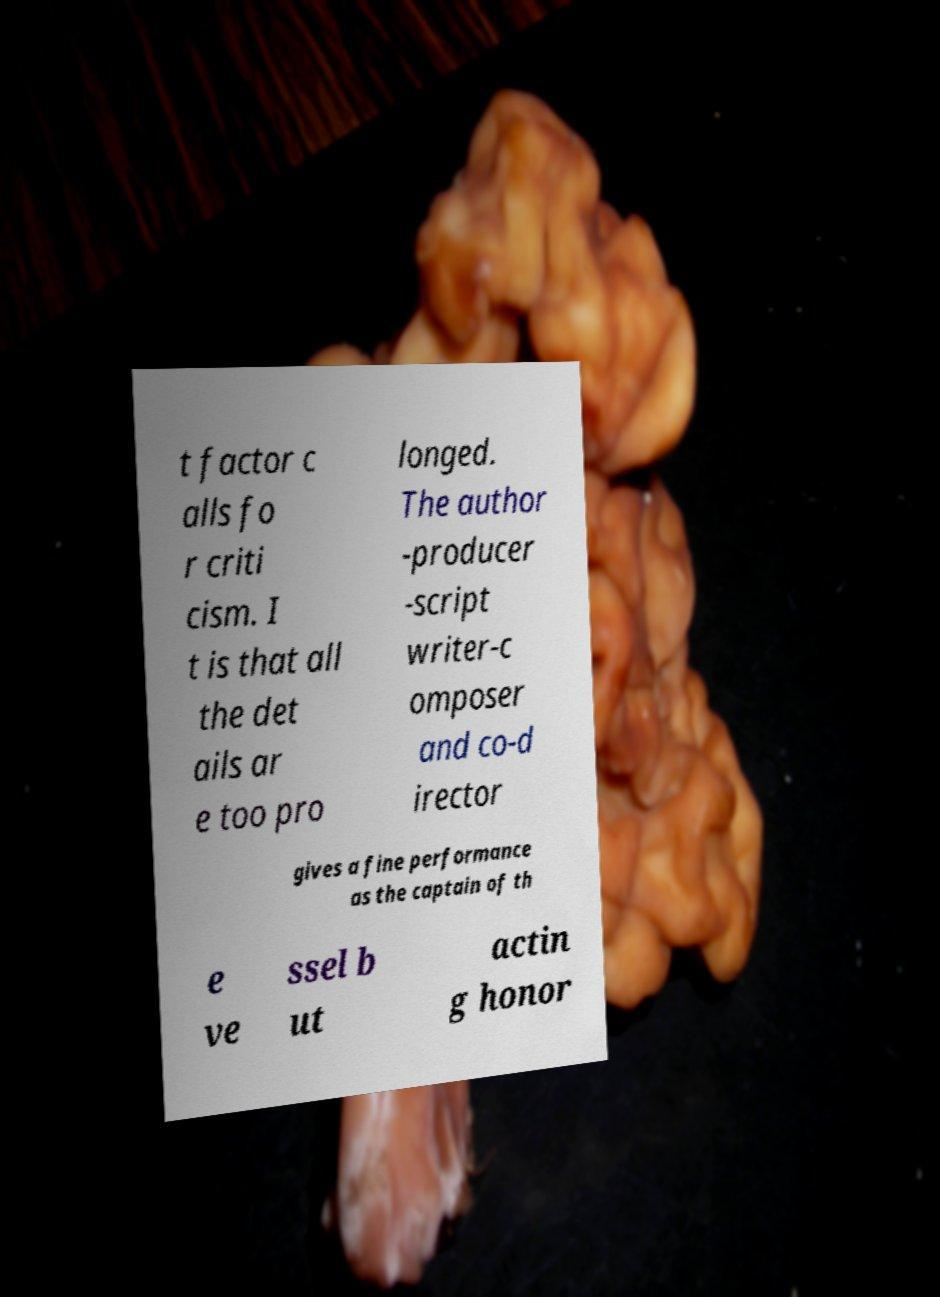Can you read and provide the text displayed in the image?This photo seems to have some interesting text. Can you extract and type it out for me? t factor c alls fo r criti cism. I t is that all the det ails ar e too pro longed. The author -producer -script writer-c omposer and co-d irector gives a fine performance as the captain of th e ve ssel b ut actin g honor 